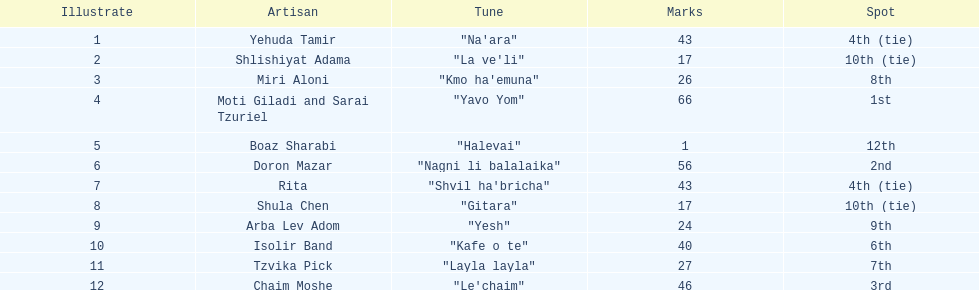Compare draws, which had the least amount of points? Boaz Sharabi. 